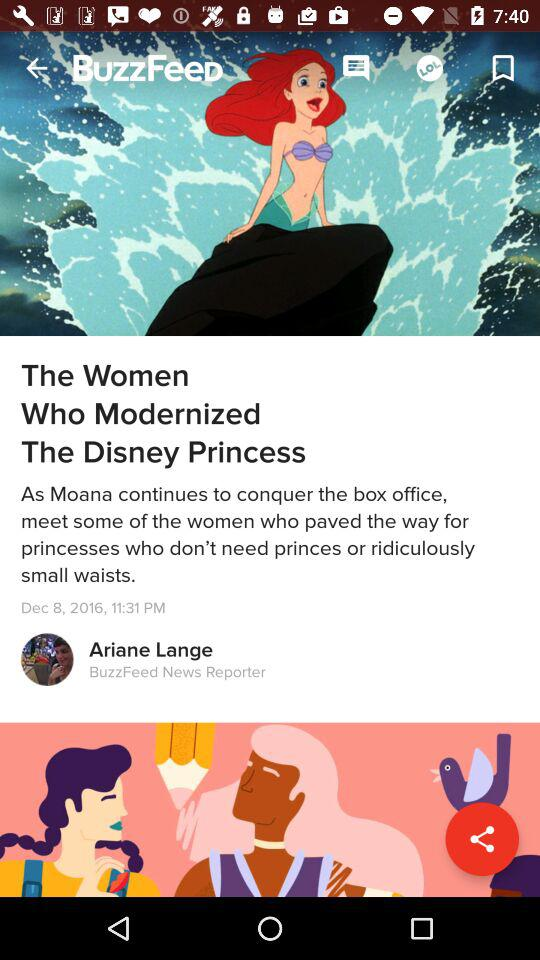Who's the author of the article? The author's name is Ariane Lange. 